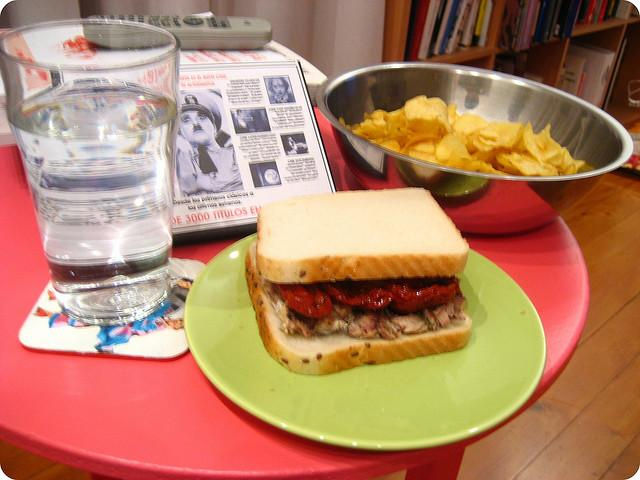What side dish is to be enjoyed with this sandwich? chips 